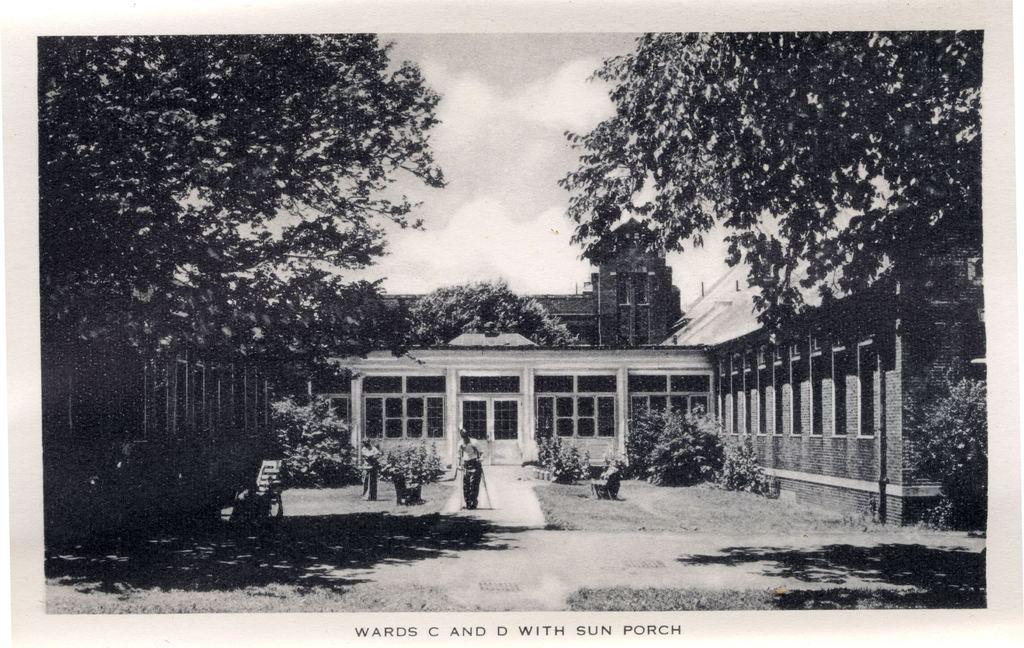What wards are shown here?
Your answer should be compact. C and d. What is the description of the photo?
Your answer should be very brief. Wards c and d with sun porch. 